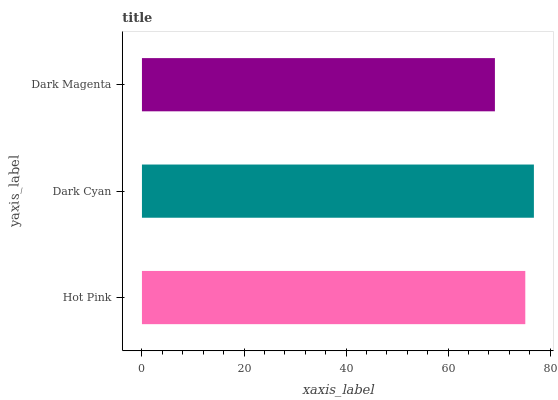Is Dark Magenta the minimum?
Answer yes or no. Yes. Is Dark Cyan the maximum?
Answer yes or no. Yes. Is Dark Cyan the minimum?
Answer yes or no. No. Is Dark Magenta the maximum?
Answer yes or no. No. Is Dark Cyan greater than Dark Magenta?
Answer yes or no. Yes. Is Dark Magenta less than Dark Cyan?
Answer yes or no. Yes. Is Dark Magenta greater than Dark Cyan?
Answer yes or no. No. Is Dark Cyan less than Dark Magenta?
Answer yes or no. No. Is Hot Pink the high median?
Answer yes or no. Yes. Is Hot Pink the low median?
Answer yes or no. Yes. Is Dark Cyan the high median?
Answer yes or no. No. Is Dark Cyan the low median?
Answer yes or no. No. 